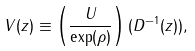Convert formula to latex. <formula><loc_0><loc_0><loc_500><loc_500>V ( z ) \equiv \left ( \frac { U } { \exp ( \rho ) } \right ) ( D ^ { - 1 } ( z ) ) ,</formula> 